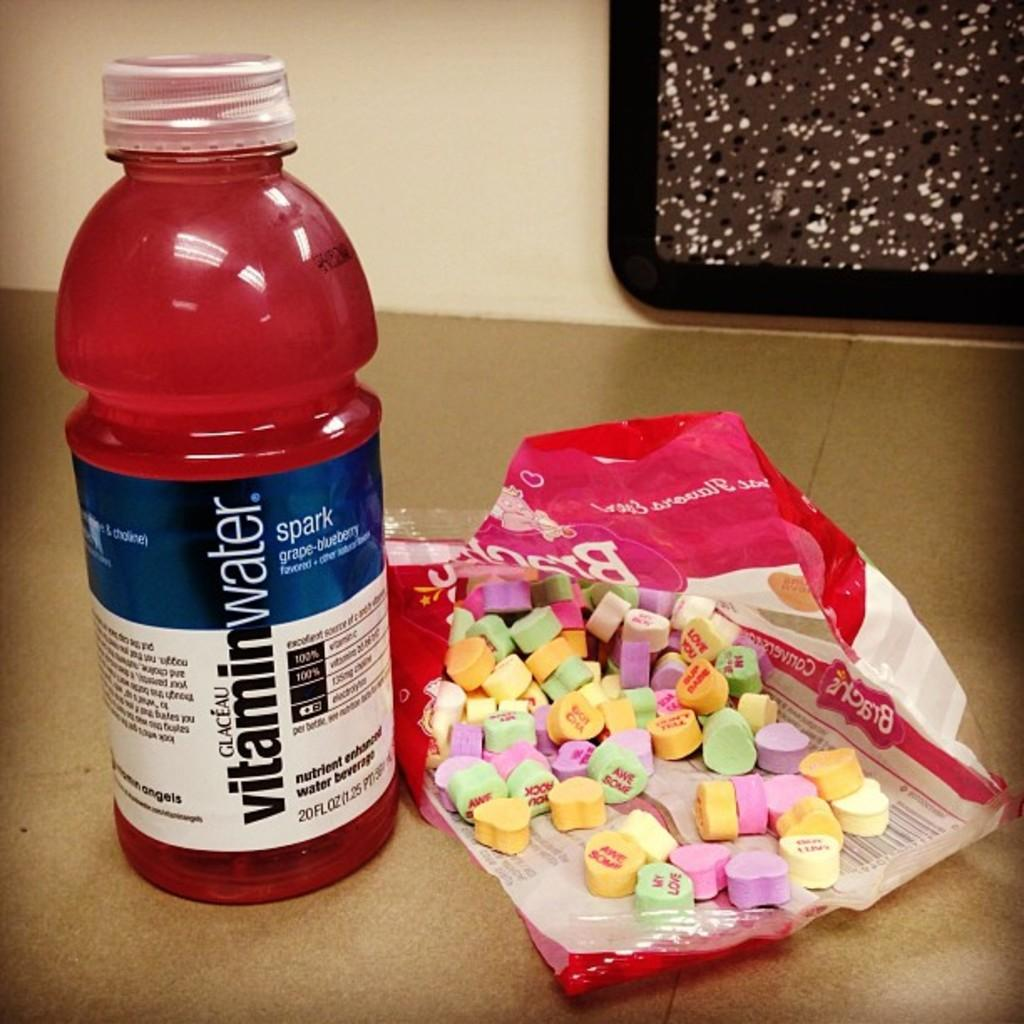What is the name of the bottle in the center of the image? The bottle in the center of the image is named "Vitamin Water." What else can be seen on the table in the image? There are tablets on a table in the image. What is visible in the background of the image? There is a wall visible in the background of the image. What color is the silver knee brace in the image? There is no silver knee brace present in the image. 